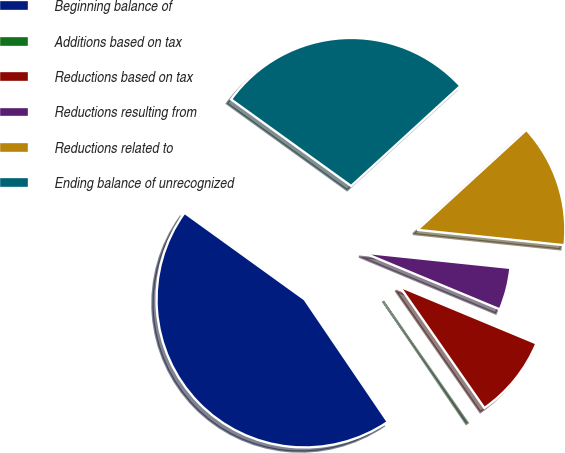Convert chart to OTSL. <chart><loc_0><loc_0><loc_500><loc_500><pie_chart><fcel>Beginning balance of<fcel>Additions based on tax<fcel>Reductions based on tax<fcel>Reductions resulting from<fcel>Reductions related to<fcel>Ending balance of unrecognized<nl><fcel>44.43%<fcel>0.19%<fcel>9.04%<fcel>4.62%<fcel>13.46%<fcel>28.25%<nl></chart> 